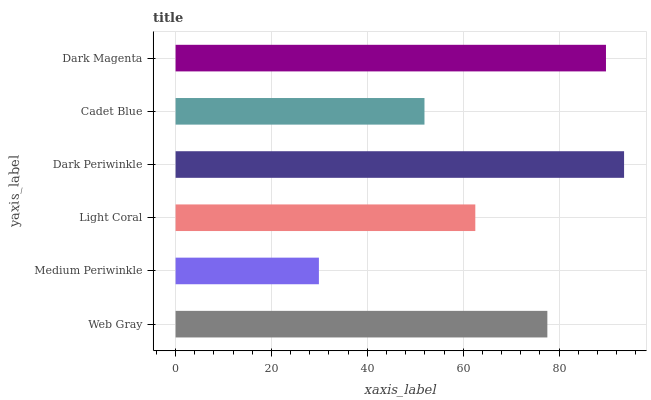Is Medium Periwinkle the minimum?
Answer yes or no. Yes. Is Dark Periwinkle the maximum?
Answer yes or no. Yes. Is Light Coral the minimum?
Answer yes or no. No. Is Light Coral the maximum?
Answer yes or no. No. Is Light Coral greater than Medium Periwinkle?
Answer yes or no. Yes. Is Medium Periwinkle less than Light Coral?
Answer yes or no. Yes. Is Medium Periwinkle greater than Light Coral?
Answer yes or no. No. Is Light Coral less than Medium Periwinkle?
Answer yes or no. No. Is Web Gray the high median?
Answer yes or no. Yes. Is Light Coral the low median?
Answer yes or no. Yes. Is Dark Periwinkle the high median?
Answer yes or no. No. Is Medium Periwinkle the low median?
Answer yes or no. No. 